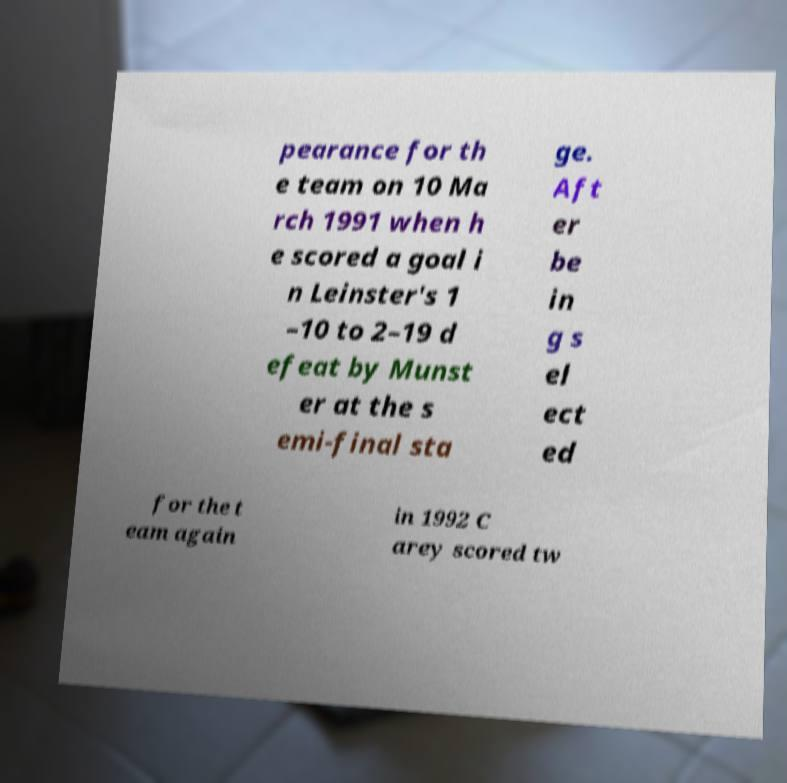Can you read and provide the text displayed in the image?This photo seems to have some interesting text. Can you extract and type it out for me? pearance for th e team on 10 Ma rch 1991 when h e scored a goal i n Leinster's 1 –10 to 2–19 d efeat by Munst er at the s emi-final sta ge. Aft er be in g s el ect ed for the t eam again in 1992 C arey scored tw 